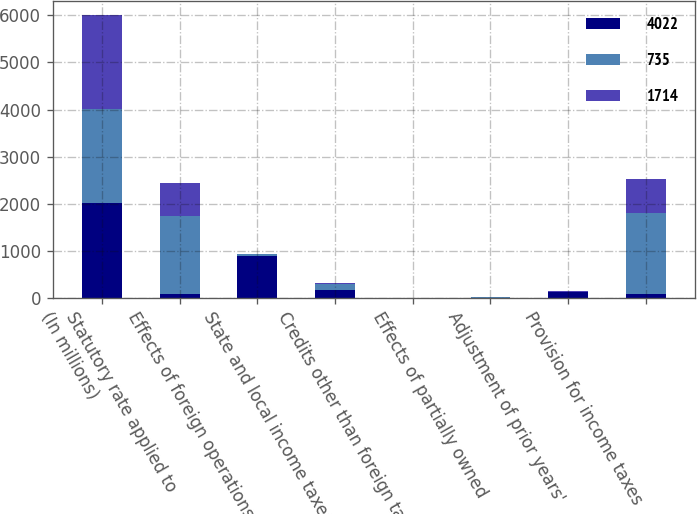<chart> <loc_0><loc_0><loc_500><loc_500><stacked_bar_chart><ecel><fcel>(In millions)<fcel>Statutory rate applied to<fcel>Effects of foreign operations<fcel>State and local income taxes<fcel>Credits other than foreign tax<fcel>Effects of partially owned<fcel>Adjustment of prior years'<fcel>Provision for income taxes<nl><fcel>4022<fcel>2006<fcel>79<fcel>888<fcel>170<fcel>2<fcel>6<fcel>119<fcel>79<nl><fcel>735<fcel>2005<fcel>1652<fcel>39<fcel>119<fcel>2<fcel>4<fcel>10<fcel>1714<nl><fcel>1714<fcel>2004<fcel>710<fcel>10<fcel>32<fcel>2<fcel>3<fcel>8<fcel>735<nl></chart> 